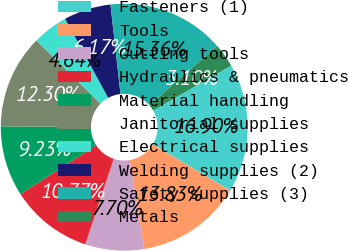Convert chart to OTSL. <chart><loc_0><loc_0><loc_500><loc_500><pie_chart><fcel>Fasteners (1)<fcel>Tools<fcel>Cutting tools<fcel>Hydraulics & pneumatics<fcel>Material handling<fcel>Janitorial supplies<fcel>Electrical supplies<fcel>Welding supplies (2)<fcel>Safety supplies (3)<fcel>Metals<nl><fcel>16.9%<fcel>13.83%<fcel>7.7%<fcel>10.77%<fcel>9.23%<fcel>12.3%<fcel>4.64%<fcel>6.17%<fcel>15.36%<fcel>3.1%<nl></chart> 